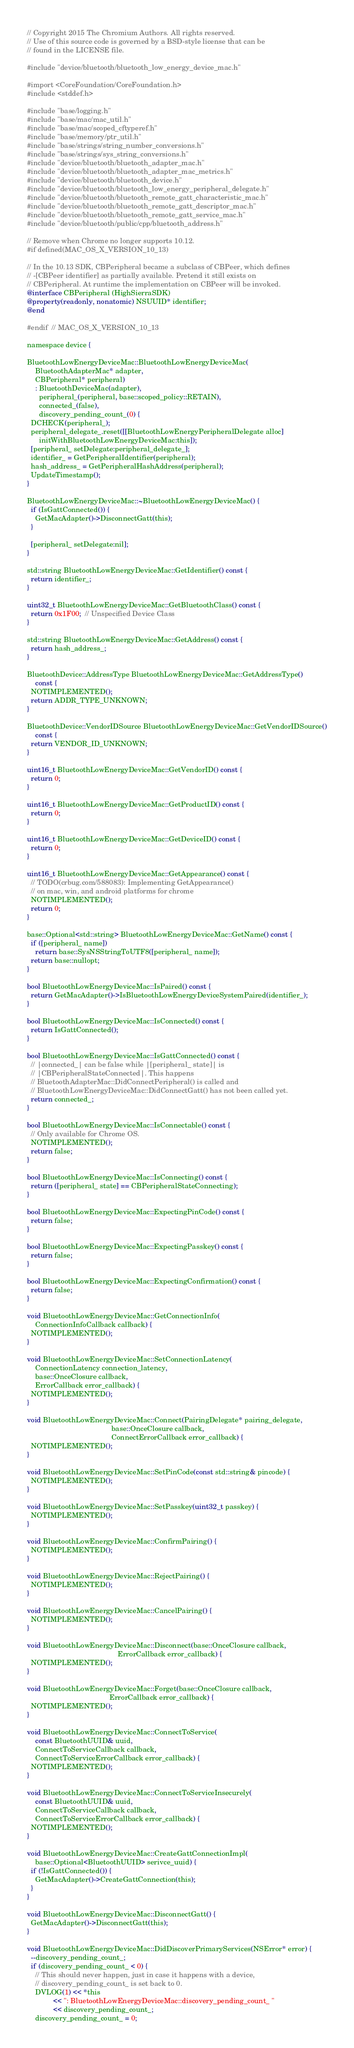<code> <loc_0><loc_0><loc_500><loc_500><_ObjectiveC_>// Copyright 2015 The Chromium Authors. All rights reserved.
// Use of this source code is governed by a BSD-style license that can be
// found in the LICENSE file.

#include "device/bluetooth/bluetooth_low_energy_device_mac.h"

#import <CoreFoundation/CoreFoundation.h>
#include <stddef.h>

#include "base/logging.h"
#include "base/mac/mac_util.h"
#include "base/mac/scoped_cftyperef.h"
#include "base/memory/ptr_util.h"
#include "base/strings/string_number_conversions.h"
#include "base/strings/sys_string_conversions.h"
#include "device/bluetooth/bluetooth_adapter_mac.h"
#include "device/bluetooth/bluetooth_adapter_mac_metrics.h"
#include "device/bluetooth/bluetooth_device.h"
#include "device/bluetooth/bluetooth_low_energy_peripheral_delegate.h"
#include "device/bluetooth/bluetooth_remote_gatt_characteristic_mac.h"
#include "device/bluetooth/bluetooth_remote_gatt_descriptor_mac.h"
#include "device/bluetooth/bluetooth_remote_gatt_service_mac.h"
#include "device/bluetooth/public/cpp/bluetooth_address.h"

// Remove when Chrome no longer supports 10.12.
#if defined(MAC_OS_X_VERSION_10_13)

// In the 10.13 SDK, CBPeripheral became a subclass of CBPeer, which defines
// -[CBPeer identifier] as partially available. Pretend it still exists on
// CBPeripheral. At runtime the implementation on CBPeer will be invoked.
@interface CBPeripheral (HighSierraSDK)
@property(readonly, nonatomic) NSUUID* identifier;
@end

#endif  // MAC_OS_X_VERSION_10_13

namespace device {

BluetoothLowEnergyDeviceMac::BluetoothLowEnergyDeviceMac(
    BluetoothAdapterMac* adapter,
    CBPeripheral* peripheral)
    : BluetoothDeviceMac(adapter),
      peripheral_(peripheral, base::scoped_policy::RETAIN),
      connected_(false),
      discovery_pending_count_(0) {
  DCHECK(peripheral_);
  peripheral_delegate_.reset([[BluetoothLowEnergyPeripheralDelegate alloc]
      initWithBluetoothLowEnergyDeviceMac:this]);
  [peripheral_ setDelegate:peripheral_delegate_];
  identifier_ = GetPeripheralIdentifier(peripheral);
  hash_address_ = GetPeripheralHashAddress(peripheral);
  UpdateTimestamp();
}

BluetoothLowEnergyDeviceMac::~BluetoothLowEnergyDeviceMac() {
  if (IsGattConnected()) {
    GetMacAdapter()->DisconnectGatt(this);
  }

  [peripheral_ setDelegate:nil];
}

std::string BluetoothLowEnergyDeviceMac::GetIdentifier() const {
  return identifier_;
}

uint32_t BluetoothLowEnergyDeviceMac::GetBluetoothClass() const {
  return 0x1F00;  // Unspecified Device Class
}

std::string BluetoothLowEnergyDeviceMac::GetAddress() const {
  return hash_address_;
}

BluetoothDevice::AddressType BluetoothLowEnergyDeviceMac::GetAddressType()
    const {
  NOTIMPLEMENTED();
  return ADDR_TYPE_UNKNOWN;
}

BluetoothDevice::VendorIDSource BluetoothLowEnergyDeviceMac::GetVendorIDSource()
    const {
  return VENDOR_ID_UNKNOWN;
}

uint16_t BluetoothLowEnergyDeviceMac::GetVendorID() const {
  return 0;
}

uint16_t BluetoothLowEnergyDeviceMac::GetProductID() const {
  return 0;
}

uint16_t BluetoothLowEnergyDeviceMac::GetDeviceID() const {
  return 0;
}

uint16_t BluetoothLowEnergyDeviceMac::GetAppearance() const {
  // TODO(crbug.com/588083): Implementing GetAppearance()
  // on mac, win, and android platforms for chrome
  NOTIMPLEMENTED();
  return 0;
}

base::Optional<std::string> BluetoothLowEnergyDeviceMac::GetName() const {
  if ([peripheral_ name])
    return base::SysNSStringToUTF8([peripheral_ name]);
  return base::nullopt;
}

bool BluetoothLowEnergyDeviceMac::IsPaired() const {
  return GetMacAdapter()->IsBluetoothLowEnergyDeviceSystemPaired(identifier_);
}

bool BluetoothLowEnergyDeviceMac::IsConnected() const {
  return IsGattConnected();
}

bool BluetoothLowEnergyDeviceMac::IsGattConnected() const {
  // |connected_| can be false while |[peripheral_ state]| is
  // |CBPeripheralStateConnected|. This happens
  // BluetoothAdapterMac::DidConnectPeripheral() is called and
  // BluetoothLowEnergyDeviceMac::DidConnectGatt() has not been called yet.
  return connected_;
}

bool BluetoothLowEnergyDeviceMac::IsConnectable() const {
  // Only available for Chrome OS.
  NOTIMPLEMENTED();
  return false;
}

bool BluetoothLowEnergyDeviceMac::IsConnecting() const {
  return ([peripheral_ state] == CBPeripheralStateConnecting);
}

bool BluetoothLowEnergyDeviceMac::ExpectingPinCode() const {
  return false;
}

bool BluetoothLowEnergyDeviceMac::ExpectingPasskey() const {
  return false;
}

bool BluetoothLowEnergyDeviceMac::ExpectingConfirmation() const {
  return false;
}

void BluetoothLowEnergyDeviceMac::GetConnectionInfo(
    ConnectionInfoCallback callback) {
  NOTIMPLEMENTED();
}

void BluetoothLowEnergyDeviceMac::SetConnectionLatency(
    ConnectionLatency connection_latency,
    base::OnceClosure callback,
    ErrorCallback error_callback) {
  NOTIMPLEMENTED();
}

void BluetoothLowEnergyDeviceMac::Connect(PairingDelegate* pairing_delegate,
                                          base::OnceClosure callback,
                                          ConnectErrorCallback error_callback) {
  NOTIMPLEMENTED();
}

void BluetoothLowEnergyDeviceMac::SetPinCode(const std::string& pincode) {
  NOTIMPLEMENTED();
}

void BluetoothLowEnergyDeviceMac::SetPasskey(uint32_t passkey) {
  NOTIMPLEMENTED();
}

void BluetoothLowEnergyDeviceMac::ConfirmPairing() {
  NOTIMPLEMENTED();
}

void BluetoothLowEnergyDeviceMac::RejectPairing() {
  NOTIMPLEMENTED();
}

void BluetoothLowEnergyDeviceMac::CancelPairing() {
  NOTIMPLEMENTED();
}

void BluetoothLowEnergyDeviceMac::Disconnect(base::OnceClosure callback,
                                             ErrorCallback error_callback) {
  NOTIMPLEMENTED();
}

void BluetoothLowEnergyDeviceMac::Forget(base::OnceClosure callback,
                                         ErrorCallback error_callback) {
  NOTIMPLEMENTED();
}

void BluetoothLowEnergyDeviceMac::ConnectToService(
    const BluetoothUUID& uuid,
    ConnectToServiceCallback callback,
    ConnectToServiceErrorCallback error_callback) {
  NOTIMPLEMENTED();
}

void BluetoothLowEnergyDeviceMac::ConnectToServiceInsecurely(
    const BluetoothUUID& uuid,
    ConnectToServiceCallback callback,
    ConnectToServiceErrorCallback error_callback) {
  NOTIMPLEMENTED();
}

void BluetoothLowEnergyDeviceMac::CreateGattConnectionImpl(
    base::Optional<BluetoothUUID> serivce_uuid) {
  if (!IsGattConnected()) {
    GetMacAdapter()->CreateGattConnection(this);
  }
}

void BluetoothLowEnergyDeviceMac::DisconnectGatt() {
  GetMacAdapter()->DisconnectGatt(this);
}

void BluetoothLowEnergyDeviceMac::DidDiscoverPrimaryServices(NSError* error) {
  --discovery_pending_count_;
  if (discovery_pending_count_ < 0) {
    // This should never happen, just in case it happens with a device,
    // discovery_pending_count_ is set back to 0.
    DVLOG(1) << *this
             << ": BluetoothLowEnergyDeviceMac::discovery_pending_count_ "
             << discovery_pending_count_;
    discovery_pending_count_ = 0;</code> 